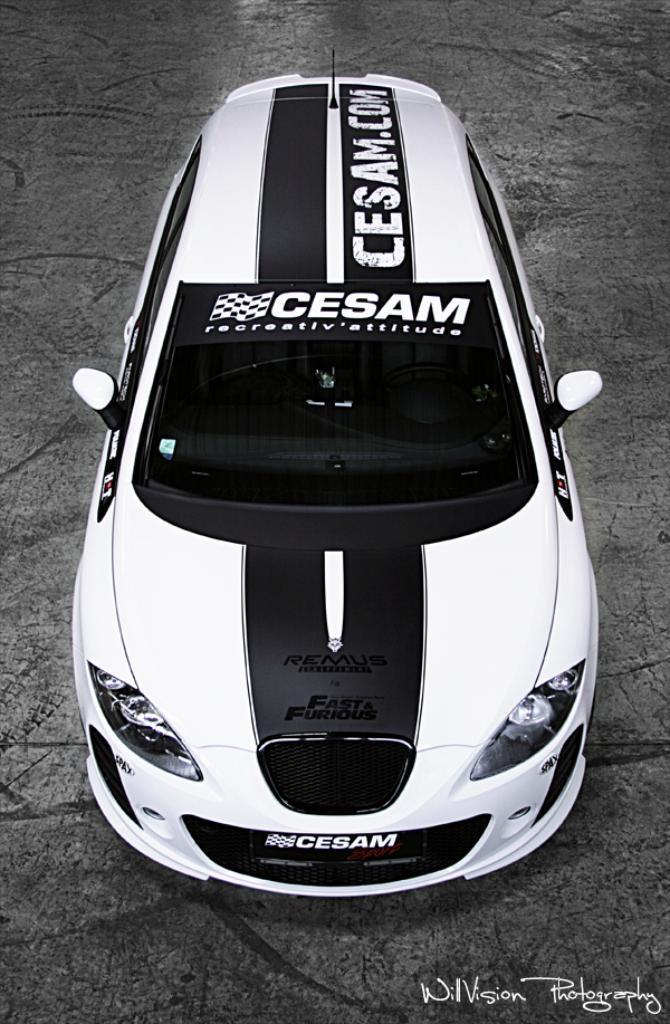Could you give a brief overview of what you see in this image? This is a black and white image , where there is a sports car on the path , and there is a watermark on the image. 